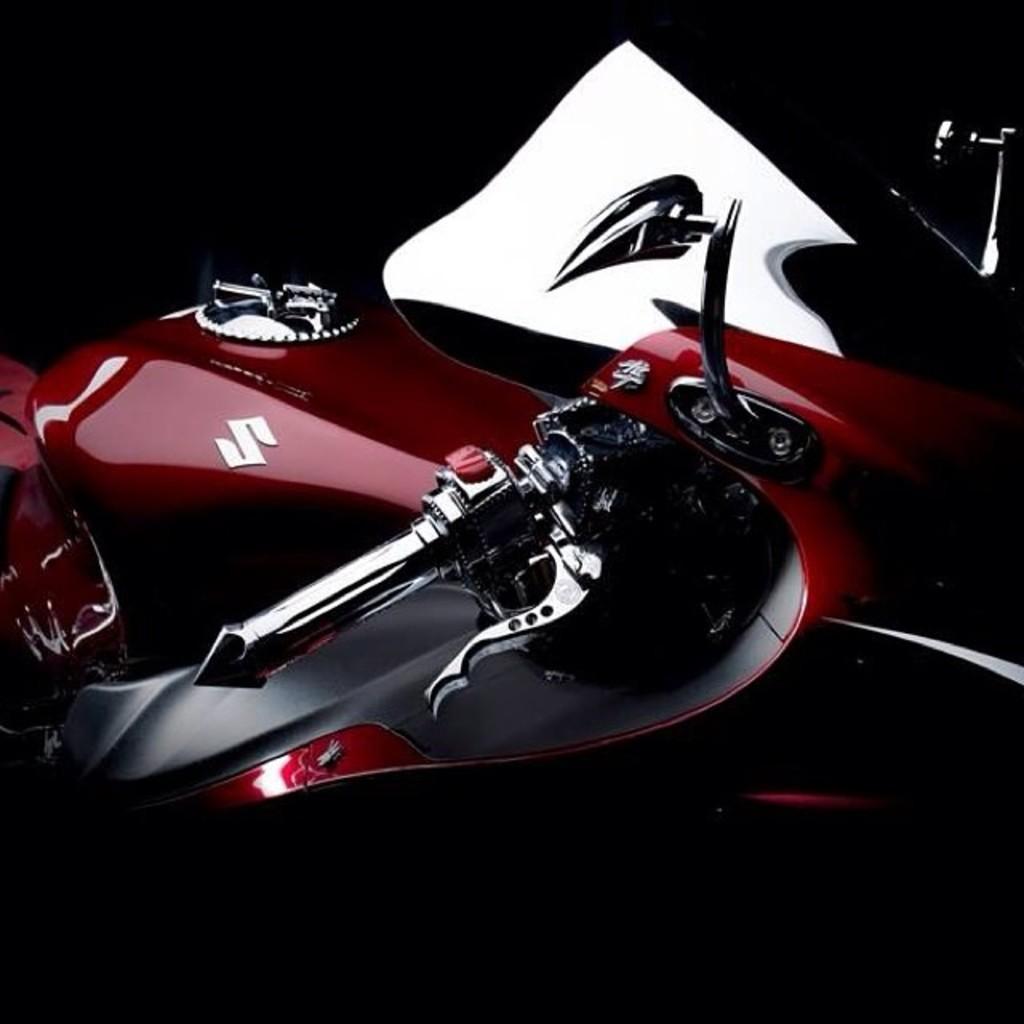In one or two sentences, can you explain what this image depicts? In this image there is a vehicle. There is a logo on the vehicle. The background is dark. 